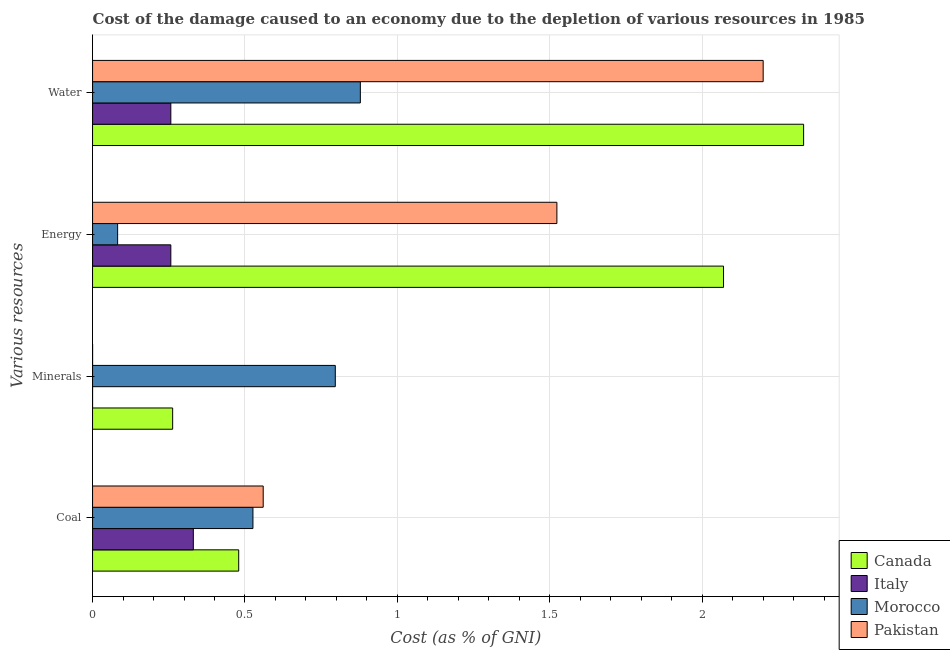How many groups of bars are there?
Give a very brief answer. 4. How many bars are there on the 1st tick from the bottom?
Your answer should be very brief. 4. What is the label of the 1st group of bars from the top?
Provide a short and direct response. Water. What is the cost of damage due to depletion of water in Italy?
Provide a succinct answer. 0.26. Across all countries, what is the maximum cost of damage due to depletion of coal?
Give a very brief answer. 0.56. Across all countries, what is the minimum cost of damage due to depletion of minerals?
Make the answer very short. 5.62379527893153e-6. In which country was the cost of damage due to depletion of water maximum?
Keep it short and to the point. Canada. What is the total cost of damage due to depletion of coal in the graph?
Give a very brief answer. 1.9. What is the difference between the cost of damage due to depletion of water in Italy and that in Pakistan?
Keep it short and to the point. -1.94. What is the difference between the cost of damage due to depletion of minerals in Italy and the cost of damage due to depletion of water in Canada?
Keep it short and to the point. -2.33. What is the average cost of damage due to depletion of energy per country?
Your answer should be very brief. 0.98. What is the difference between the cost of damage due to depletion of coal and cost of damage due to depletion of water in Italy?
Make the answer very short. 0.07. What is the ratio of the cost of damage due to depletion of energy in Morocco to that in Pakistan?
Offer a very short reply. 0.05. Is the cost of damage due to depletion of minerals in Canada less than that in Pakistan?
Your answer should be compact. No. What is the difference between the highest and the second highest cost of damage due to depletion of coal?
Ensure brevity in your answer.  0.03. What is the difference between the highest and the lowest cost of damage due to depletion of energy?
Offer a very short reply. 1.99. In how many countries, is the cost of damage due to depletion of minerals greater than the average cost of damage due to depletion of minerals taken over all countries?
Provide a short and direct response. 1. Is it the case that in every country, the sum of the cost of damage due to depletion of coal and cost of damage due to depletion of energy is greater than the sum of cost of damage due to depletion of minerals and cost of damage due to depletion of water?
Your response must be concise. No. Is it the case that in every country, the sum of the cost of damage due to depletion of coal and cost of damage due to depletion of minerals is greater than the cost of damage due to depletion of energy?
Give a very brief answer. No. Are all the bars in the graph horizontal?
Your answer should be compact. Yes. What is the difference between two consecutive major ticks on the X-axis?
Your answer should be very brief. 0.5. Are the values on the major ticks of X-axis written in scientific E-notation?
Your answer should be very brief. No. Where does the legend appear in the graph?
Give a very brief answer. Bottom right. What is the title of the graph?
Offer a terse response. Cost of the damage caused to an economy due to the depletion of various resources in 1985 . What is the label or title of the X-axis?
Keep it short and to the point. Cost (as % of GNI). What is the label or title of the Y-axis?
Your answer should be very brief. Various resources. What is the Cost (as % of GNI) in Canada in Coal?
Provide a succinct answer. 0.48. What is the Cost (as % of GNI) in Italy in Coal?
Offer a very short reply. 0.33. What is the Cost (as % of GNI) in Morocco in Coal?
Make the answer very short. 0.53. What is the Cost (as % of GNI) in Pakistan in Coal?
Your answer should be very brief. 0.56. What is the Cost (as % of GNI) of Canada in Minerals?
Your answer should be very brief. 0.26. What is the Cost (as % of GNI) in Italy in Minerals?
Offer a terse response. 5.62379527893153e-6. What is the Cost (as % of GNI) in Morocco in Minerals?
Offer a terse response. 0.8. What is the Cost (as % of GNI) of Pakistan in Minerals?
Offer a very short reply. 7.60490362315771e-5. What is the Cost (as % of GNI) of Canada in Energy?
Give a very brief answer. 2.07. What is the Cost (as % of GNI) in Italy in Energy?
Offer a terse response. 0.26. What is the Cost (as % of GNI) in Morocco in Energy?
Provide a short and direct response. 0.08. What is the Cost (as % of GNI) of Pakistan in Energy?
Keep it short and to the point. 1.52. What is the Cost (as % of GNI) of Canada in Water?
Offer a terse response. 2.33. What is the Cost (as % of GNI) of Italy in Water?
Your answer should be very brief. 0.26. What is the Cost (as % of GNI) of Morocco in Water?
Make the answer very short. 0.88. What is the Cost (as % of GNI) of Pakistan in Water?
Your answer should be compact. 2.2. Across all Various resources, what is the maximum Cost (as % of GNI) in Canada?
Ensure brevity in your answer.  2.33. Across all Various resources, what is the maximum Cost (as % of GNI) in Italy?
Your answer should be very brief. 0.33. Across all Various resources, what is the maximum Cost (as % of GNI) of Morocco?
Give a very brief answer. 0.88. Across all Various resources, what is the maximum Cost (as % of GNI) in Pakistan?
Make the answer very short. 2.2. Across all Various resources, what is the minimum Cost (as % of GNI) of Canada?
Offer a very short reply. 0.26. Across all Various resources, what is the minimum Cost (as % of GNI) of Italy?
Make the answer very short. 5.62379527893153e-6. Across all Various resources, what is the minimum Cost (as % of GNI) of Morocco?
Offer a terse response. 0.08. Across all Various resources, what is the minimum Cost (as % of GNI) of Pakistan?
Offer a very short reply. 7.60490362315771e-5. What is the total Cost (as % of GNI) of Canada in the graph?
Offer a terse response. 5.14. What is the total Cost (as % of GNI) in Italy in the graph?
Make the answer very short. 0.84. What is the total Cost (as % of GNI) in Morocco in the graph?
Give a very brief answer. 2.28. What is the total Cost (as % of GNI) in Pakistan in the graph?
Offer a terse response. 4.28. What is the difference between the Cost (as % of GNI) in Canada in Coal and that in Minerals?
Keep it short and to the point. 0.22. What is the difference between the Cost (as % of GNI) of Italy in Coal and that in Minerals?
Keep it short and to the point. 0.33. What is the difference between the Cost (as % of GNI) in Morocco in Coal and that in Minerals?
Provide a succinct answer. -0.27. What is the difference between the Cost (as % of GNI) of Pakistan in Coal and that in Minerals?
Offer a terse response. 0.56. What is the difference between the Cost (as % of GNI) of Canada in Coal and that in Energy?
Ensure brevity in your answer.  -1.59. What is the difference between the Cost (as % of GNI) in Italy in Coal and that in Energy?
Your response must be concise. 0.07. What is the difference between the Cost (as % of GNI) in Morocco in Coal and that in Energy?
Provide a succinct answer. 0.44. What is the difference between the Cost (as % of GNI) of Pakistan in Coal and that in Energy?
Give a very brief answer. -0.96. What is the difference between the Cost (as % of GNI) in Canada in Coal and that in Water?
Offer a terse response. -1.85. What is the difference between the Cost (as % of GNI) in Italy in Coal and that in Water?
Your response must be concise. 0.07. What is the difference between the Cost (as % of GNI) of Morocco in Coal and that in Water?
Provide a succinct answer. -0.35. What is the difference between the Cost (as % of GNI) of Pakistan in Coal and that in Water?
Make the answer very short. -1.64. What is the difference between the Cost (as % of GNI) of Canada in Minerals and that in Energy?
Offer a terse response. -1.81. What is the difference between the Cost (as % of GNI) of Italy in Minerals and that in Energy?
Your response must be concise. -0.26. What is the difference between the Cost (as % of GNI) in Morocco in Minerals and that in Energy?
Offer a terse response. 0.71. What is the difference between the Cost (as % of GNI) of Pakistan in Minerals and that in Energy?
Your answer should be very brief. -1.52. What is the difference between the Cost (as % of GNI) of Canada in Minerals and that in Water?
Your answer should be very brief. -2.07. What is the difference between the Cost (as % of GNI) of Italy in Minerals and that in Water?
Offer a terse response. -0.26. What is the difference between the Cost (as % of GNI) of Morocco in Minerals and that in Water?
Keep it short and to the point. -0.08. What is the difference between the Cost (as % of GNI) of Canada in Energy and that in Water?
Give a very brief answer. -0.26. What is the difference between the Cost (as % of GNI) in Morocco in Energy and that in Water?
Your answer should be very brief. -0.8. What is the difference between the Cost (as % of GNI) in Pakistan in Energy and that in Water?
Your answer should be compact. -0.68. What is the difference between the Cost (as % of GNI) of Canada in Coal and the Cost (as % of GNI) of Italy in Minerals?
Provide a succinct answer. 0.48. What is the difference between the Cost (as % of GNI) in Canada in Coal and the Cost (as % of GNI) in Morocco in Minerals?
Provide a succinct answer. -0.32. What is the difference between the Cost (as % of GNI) of Canada in Coal and the Cost (as % of GNI) of Pakistan in Minerals?
Make the answer very short. 0.48. What is the difference between the Cost (as % of GNI) of Italy in Coal and the Cost (as % of GNI) of Morocco in Minerals?
Your response must be concise. -0.47. What is the difference between the Cost (as % of GNI) in Italy in Coal and the Cost (as % of GNI) in Pakistan in Minerals?
Your answer should be very brief. 0.33. What is the difference between the Cost (as % of GNI) in Morocco in Coal and the Cost (as % of GNI) in Pakistan in Minerals?
Provide a short and direct response. 0.53. What is the difference between the Cost (as % of GNI) of Canada in Coal and the Cost (as % of GNI) of Italy in Energy?
Ensure brevity in your answer.  0.22. What is the difference between the Cost (as % of GNI) in Canada in Coal and the Cost (as % of GNI) in Morocco in Energy?
Make the answer very short. 0.4. What is the difference between the Cost (as % of GNI) of Canada in Coal and the Cost (as % of GNI) of Pakistan in Energy?
Keep it short and to the point. -1.04. What is the difference between the Cost (as % of GNI) in Italy in Coal and the Cost (as % of GNI) in Morocco in Energy?
Provide a succinct answer. 0.25. What is the difference between the Cost (as % of GNI) in Italy in Coal and the Cost (as % of GNI) in Pakistan in Energy?
Offer a very short reply. -1.19. What is the difference between the Cost (as % of GNI) in Morocco in Coal and the Cost (as % of GNI) in Pakistan in Energy?
Keep it short and to the point. -1. What is the difference between the Cost (as % of GNI) of Canada in Coal and the Cost (as % of GNI) of Italy in Water?
Provide a succinct answer. 0.22. What is the difference between the Cost (as % of GNI) of Canada in Coal and the Cost (as % of GNI) of Morocco in Water?
Your response must be concise. -0.4. What is the difference between the Cost (as % of GNI) of Canada in Coal and the Cost (as % of GNI) of Pakistan in Water?
Keep it short and to the point. -1.72. What is the difference between the Cost (as % of GNI) of Italy in Coal and the Cost (as % of GNI) of Morocco in Water?
Give a very brief answer. -0.55. What is the difference between the Cost (as % of GNI) in Italy in Coal and the Cost (as % of GNI) in Pakistan in Water?
Your response must be concise. -1.87. What is the difference between the Cost (as % of GNI) of Morocco in Coal and the Cost (as % of GNI) of Pakistan in Water?
Your response must be concise. -1.67. What is the difference between the Cost (as % of GNI) in Canada in Minerals and the Cost (as % of GNI) in Italy in Energy?
Make the answer very short. 0.01. What is the difference between the Cost (as % of GNI) of Canada in Minerals and the Cost (as % of GNI) of Morocco in Energy?
Make the answer very short. 0.18. What is the difference between the Cost (as % of GNI) of Canada in Minerals and the Cost (as % of GNI) of Pakistan in Energy?
Your answer should be compact. -1.26. What is the difference between the Cost (as % of GNI) in Italy in Minerals and the Cost (as % of GNI) in Morocco in Energy?
Keep it short and to the point. -0.08. What is the difference between the Cost (as % of GNI) of Italy in Minerals and the Cost (as % of GNI) of Pakistan in Energy?
Make the answer very short. -1.52. What is the difference between the Cost (as % of GNI) in Morocco in Minerals and the Cost (as % of GNI) in Pakistan in Energy?
Offer a terse response. -0.73. What is the difference between the Cost (as % of GNI) of Canada in Minerals and the Cost (as % of GNI) of Italy in Water?
Provide a short and direct response. 0.01. What is the difference between the Cost (as % of GNI) in Canada in Minerals and the Cost (as % of GNI) in Morocco in Water?
Provide a succinct answer. -0.62. What is the difference between the Cost (as % of GNI) in Canada in Minerals and the Cost (as % of GNI) in Pakistan in Water?
Ensure brevity in your answer.  -1.94. What is the difference between the Cost (as % of GNI) in Italy in Minerals and the Cost (as % of GNI) in Morocco in Water?
Provide a succinct answer. -0.88. What is the difference between the Cost (as % of GNI) in Morocco in Minerals and the Cost (as % of GNI) in Pakistan in Water?
Your response must be concise. -1.4. What is the difference between the Cost (as % of GNI) in Canada in Energy and the Cost (as % of GNI) in Italy in Water?
Offer a very short reply. 1.81. What is the difference between the Cost (as % of GNI) in Canada in Energy and the Cost (as % of GNI) in Morocco in Water?
Keep it short and to the point. 1.19. What is the difference between the Cost (as % of GNI) in Canada in Energy and the Cost (as % of GNI) in Pakistan in Water?
Offer a very short reply. -0.13. What is the difference between the Cost (as % of GNI) of Italy in Energy and the Cost (as % of GNI) of Morocco in Water?
Your answer should be very brief. -0.62. What is the difference between the Cost (as % of GNI) in Italy in Energy and the Cost (as % of GNI) in Pakistan in Water?
Provide a succinct answer. -1.94. What is the difference between the Cost (as % of GNI) of Morocco in Energy and the Cost (as % of GNI) of Pakistan in Water?
Provide a short and direct response. -2.12. What is the average Cost (as % of GNI) of Canada per Various resources?
Give a very brief answer. 1.29. What is the average Cost (as % of GNI) of Italy per Various resources?
Offer a very short reply. 0.21. What is the average Cost (as % of GNI) of Morocco per Various resources?
Offer a very short reply. 0.57. What is the average Cost (as % of GNI) of Pakistan per Various resources?
Give a very brief answer. 1.07. What is the difference between the Cost (as % of GNI) in Canada and Cost (as % of GNI) in Italy in Coal?
Ensure brevity in your answer.  0.15. What is the difference between the Cost (as % of GNI) in Canada and Cost (as % of GNI) in Morocco in Coal?
Make the answer very short. -0.05. What is the difference between the Cost (as % of GNI) in Canada and Cost (as % of GNI) in Pakistan in Coal?
Offer a terse response. -0.08. What is the difference between the Cost (as % of GNI) of Italy and Cost (as % of GNI) of Morocco in Coal?
Provide a short and direct response. -0.2. What is the difference between the Cost (as % of GNI) of Italy and Cost (as % of GNI) of Pakistan in Coal?
Keep it short and to the point. -0.23. What is the difference between the Cost (as % of GNI) of Morocco and Cost (as % of GNI) of Pakistan in Coal?
Provide a succinct answer. -0.03. What is the difference between the Cost (as % of GNI) of Canada and Cost (as % of GNI) of Italy in Minerals?
Your answer should be compact. 0.26. What is the difference between the Cost (as % of GNI) of Canada and Cost (as % of GNI) of Morocco in Minerals?
Give a very brief answer. -0.53. What is the difference between the Cost (as % of GNI) of Canada and Cost (as % of GNI) of Pakistan in Minerals?
Offer a very short reply. 0.26. What is the difference between the Cost (as % of GNI) of Italy and Cost (as % of GNI) of Morocco in Minerals?
Provide a succinct answer. -0.8. What is the difference between the Cost (as % of GNI) of Italy and Cost (as % of GNI) of Pakistan in Minerals?
Make the answer very short. -0. What is the difference between the Cost (as % of GNI) of Morocco and Cost (as % of GNI) of Pakistan in Minerals?
Your response must be concise. 0.8. What is the difference between the Cost (as % of GNI) of Canada and Cost (as % of GNI) of Italy in Energy?
Offer a very short reply. 1.81. What is the difference between the Cost (as % of GNI) of Canada and Cost (as % of GNI) of Morocco in Energy?
Offer a terse response. 1.99. What is the difference between the Cost (as % of GNI) of Canada and Cost (as % of GNI) of Pakistan in Energy?
Offer a very short reply. 0.55. What is the difference between the Cost (as % of GNI) of Italy and Cost (as % of GNI) of Morocco in Energy?
Offer a very short reply. 0.17. What is the difference between the Cost (as % of GNI) of Italy and Cost (as % of GNI) of Pakistan in Energy?
Give a very brief answer. -1.27. What is the difference between the Cost (as % of GNI) in Morocco and Cost (as % of GNI) in Pakistan in Energy?
Provide a succinct answer. -1.44. What is the difference between the Cost (as % of GNI) in Canada and Cost (as % of GNI) in Italy in Water?
Provide a succinct answer. 2.08. What is the difference between the Cost (as % of GNI) in Canada and Cost (as % of GNI) in Morocco in Water?
Provide a short and direct response. 1.45. What is the difference between the Cost (as % of GNI) of Canada and Cost (as % of GNI) of Pakistan in Water?
Your answer should be very brief. 0.13. What is the difference between the Cost (as % of GNI) of Italy and Cost (as % of GNI) of Morocco in Water?
Offer a terse response. -0.62. What is the difference between the Cost (as % of GNI) in Italy and Cost (as % of GNI) in Pakistan in Water?
Provide a succinct answer. -1.94. What is the difference between the Cost (as % of GNI) of Morocco and Cost (as % of GNI) of Pakistan in Water?
Make the answer very short. -1.32. What is the ratio of the Cost (as % of GNI) in Canada in Coal to that in Minerals?
Provide a short and direct response. 1.82. What is the ratio of the Cost (as % of GNI) in Italy in Coal to that in Minerals?
Your response must be concise. 5.88e+04. What is the ratio of the Cost (as % of GNI) of Morocco in Coal to that in Minerals?
Your answer should be very brief. 0.66. What is the ratio of the Cost (as % of GNI) in Pakistan in Coal to that in Minerals?
Offer a terse response. 7361.03. What is the ratio of the Cost (as % of GNI) in Canada in Coal to that in Energy?
Provide a succinct answer. 0.23. What is the ratio of the Cost (as % of GNI) of Italy in Coal to that in Energy?
Offer a terse response. 1.29. What is the ratio of the Cost (as % of GNI) of Morocco in Coal to that in Energy?
Provide a succinct answer. 6.4. What is the ratio of the Cost (as % of GNI) of Pakistan in Coal to that in Energy?
Make the answer very short. 0.37. What is the ratio of the Cost (as % of GNI) in Canada in Coal to that in Water?
Provide a succinct answer. 0.21. What is the ratio of the Cost (as % of GNI) of Italy in Coal to that in Water?
Your answer should be very brief. 1.29. What is the ratio of the Cost (as % of GNI) in Morocco in Coal to that in Water?
Make the answer very short. 0.6. What is the ratio of the Cost (as % of GNI) in Pakistan in Coal to that in Water?
Offer a terse response. 0.25. What is the ratio of the Cost (as % of GNI) in Canada in Minerals to that in Energy?
Give a very brief answer. 0.13. What is the ratio of the Cost (as % of GNI) in Italy in Minerals to that in Energy?
Provide a succinct answer. 0. What is the ratio of the Cost (as % of GNI) in Morocco in Minerals to that in Energy?
Your answer should be very brief. 9.69. What is the ratio of the Cost (as % of GNI) of Pakistan in Minerals to that in Energy?
Give a very brief answer. 0. What is the ratio of the Cost (as % of GNI) of Canada in Minerals to that in Water?
Offer a very short reply. 0.11. What is the ratio of the Cost (as % of GNI) of Italy in Minerals to that in Water?
Offer a very short reply. 0. What is the ratio of the Cost (as % of GNI) in Morocco in Minerals to that in Water?
Offer a very short reply. 0.91. What is the ratio of the Cost (as % of GNI) of Pakistan in Minerals to that in Water?
Your answer should be very brief. 0. What is the ratio of the Cost (as % of GNI) of Canada in Energy to that in Water?
Offer a terse response. 0.89. What is the ratio of the Cost (as % of GNI) of Morocco in Energy to that in Water?
Keep it short and to the point. 0.09. What is the ratio of the Cost (as % of GNI) of Pakistan in Energy to that in Water?
Your answer should be compact. 0.69. What is the difference between the highest and the second highest Cost (as % of GNI) in Canada?
Keep it short and to the point. 0.26. What is the difference between the highest and the second highest Cost (as % of GNI) of Italy?
Your answer should be compact. 0.07. What is the difference between the highest and the second highest Cost (as % of GNI) in Morocco?
Ensure brevity in your answer.  0.08. What is the difference between the highest and the second highest Cost (as % of GNI) in Pakistan?
Your answer should be very brief. 0.68. What is the difference between the highest and the lowest Cost (as % of GNI) in Canada?
Ensure brevity in your answer.  2.07. What is the difference between the highest and the lowest Cost (as % of GNI) of Italy?
Ensure brevity in your answer.  0.33. What is the difference between the highest and the lowest Cost (as % of GNI) in Morocco?
Make the answer very short. 0.8. What is the difference between the highest and the lowest Cost (as % of GNI) of Pakistan?
Provide a succinct answer. 2.2. 